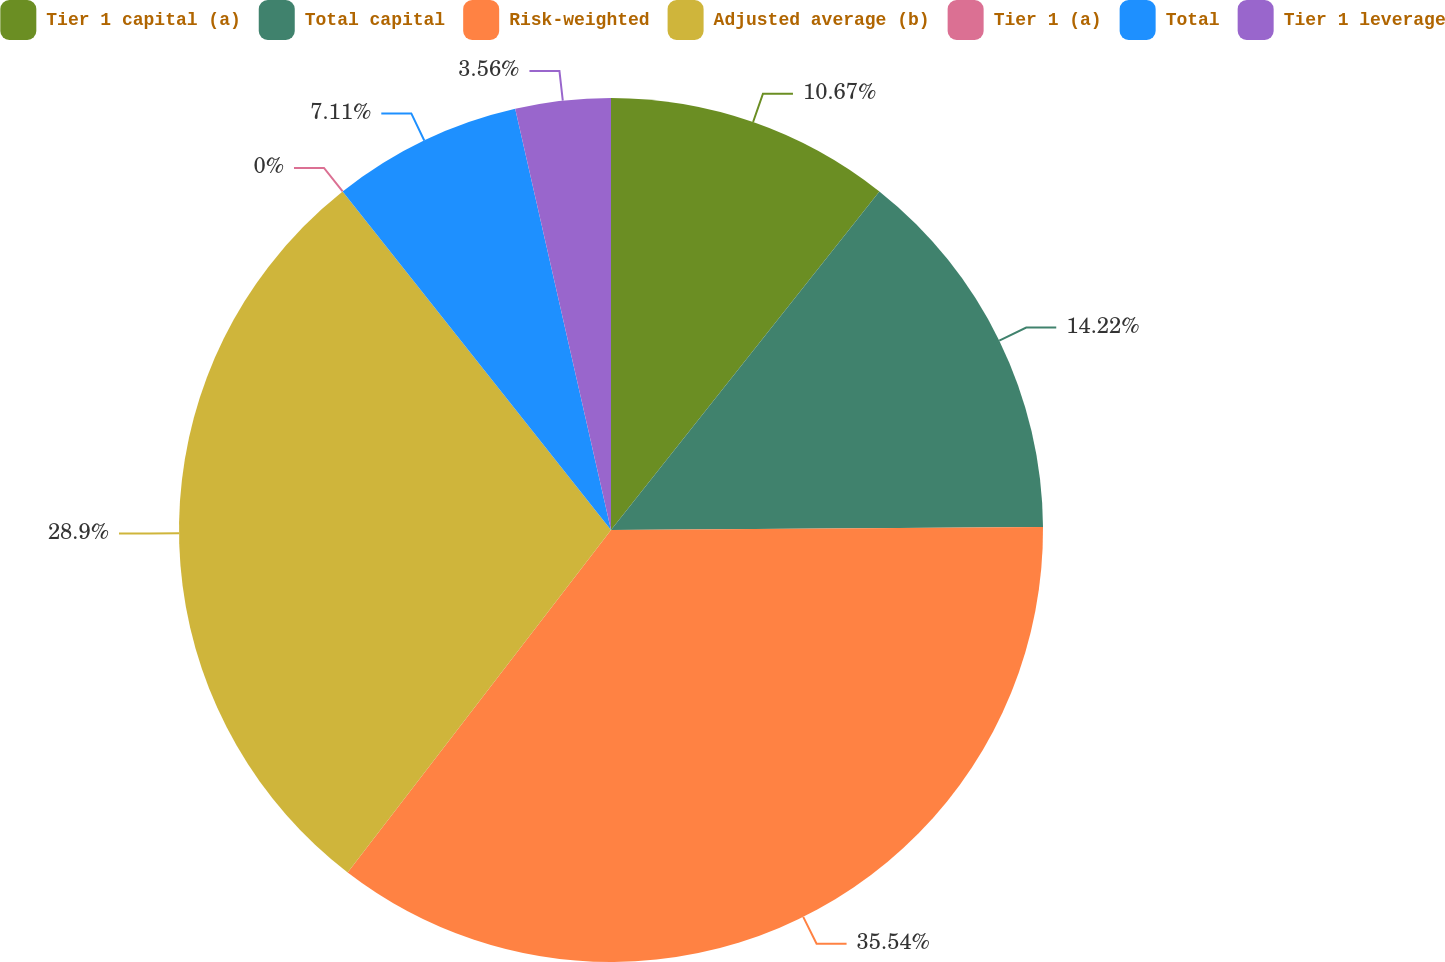<chart> <loc_0><loc_0><loc_500><loc_500><pie_chart><fcel>Tier 1 capital (a)<fcel>Total capital<fcel>Risk-weighted<fcel>Adjusted average (b)<fcel>Tier 1 (a)<fcel>Total<fcel>Tier 1 leverage<nl><fcel>10.67%<fcel>14.22%<fcel>35.55%<fcel>28.9%<fcel>0.0%<fcel>7.11%<fcel>3.56%<nl></chart> 